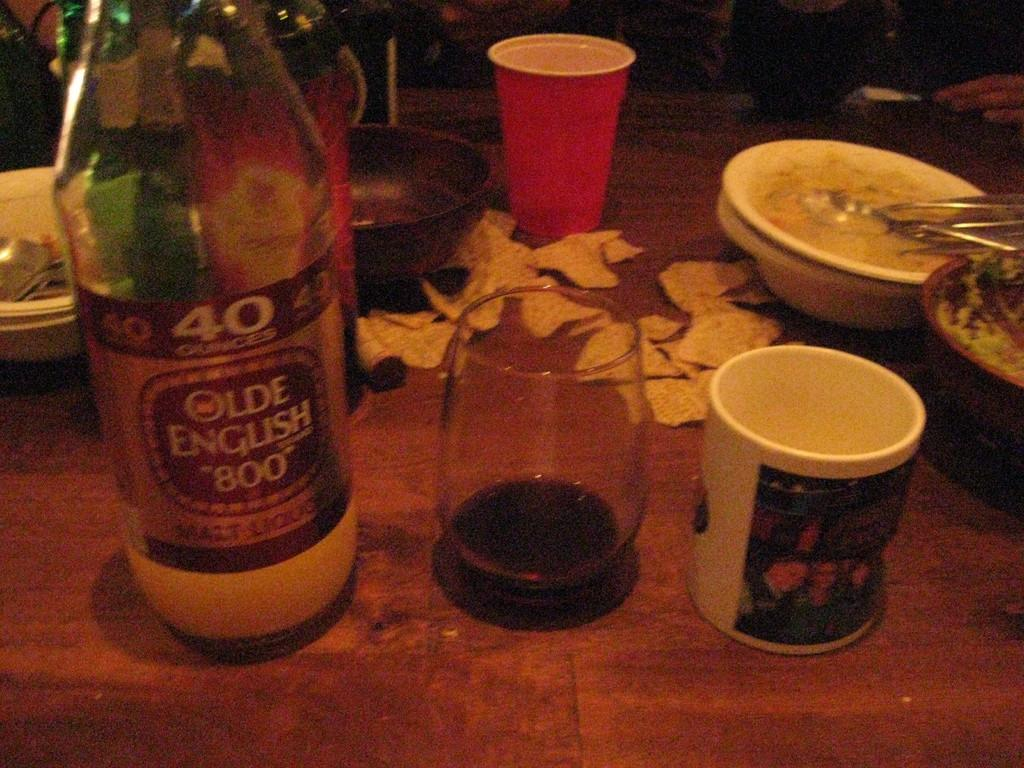What type of furniture is present in the image? There is a table in the image. What is placed on the table? There is a bottle, glasses, cups, bowls, and spoons on the table. Are there any food items on the table? Yes, there are food items on the table. How many plastic sheep are visible on the table in the image? There are no plastic sheep present in the image. What word is used to stop the table from moving in the image? The image does not show the table moving, so there is no need to stop it. 